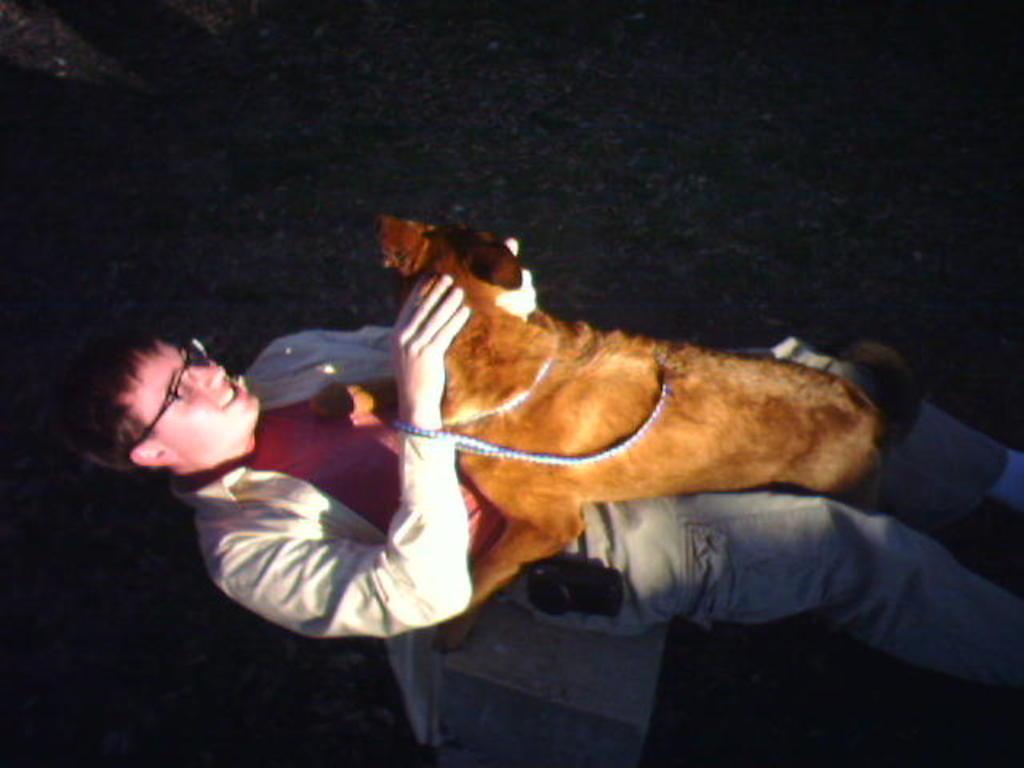Can you describe this image briefly? In the foreground of the picture there is a man lying on the grass, on him there is a dog. It is dark. 